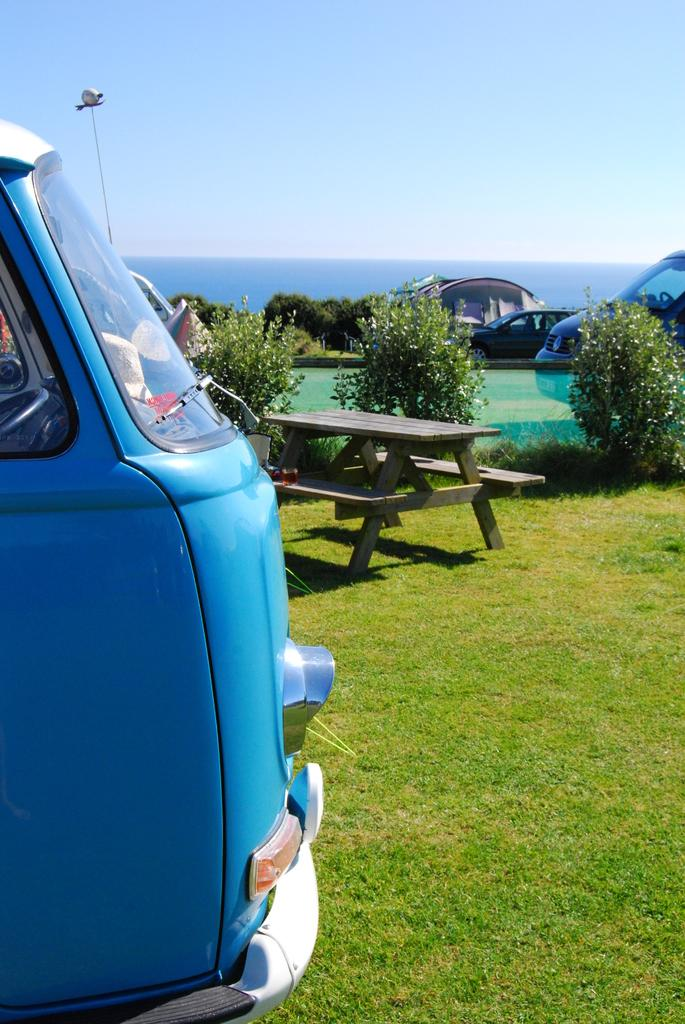What type of vehicle is on the left side of the image? There is a van on the left side of the image. What object is located in the middle of the image? There is a bench in the middle of the image. What type of transportation is on the right side of the image? There are cars on the right side of the image. What type of vegetation is present in the image? There is a plant in the image. What part of the natural environment is visible in the image? The sky is visible at the top of the image, and grass is visible at the bottom of the image. Where is the man sitting on the table in the image? There is no man sitting on a table in the image. What type of explosive device is present in the image? There is no bomb or any explosive device present in the image. 